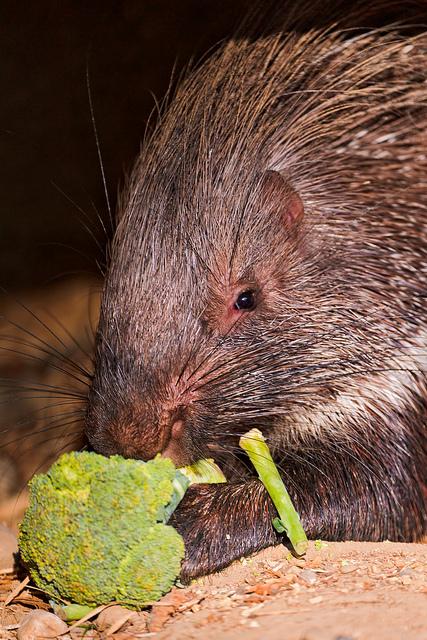Is the rat content?
Short answer required. Yes. What animal is this?
Quick response, please. Porcupine. What is the rat eating?
Answer briefly. Broccoli. 